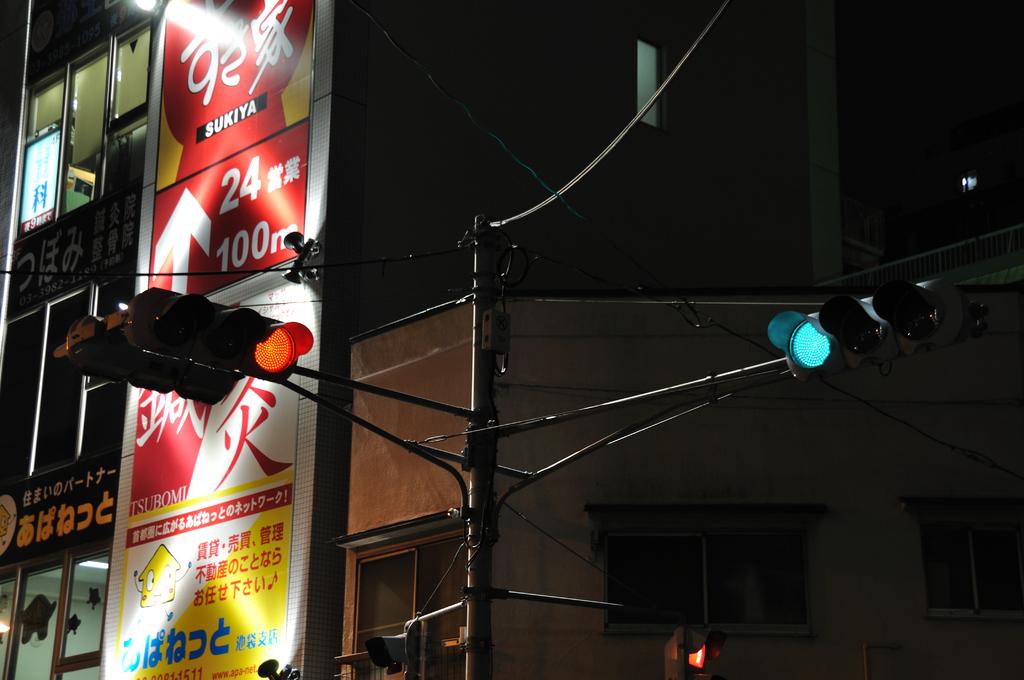What are the two numbers on the red sign?
Ensure brevity in your answer.  24 and 100. 